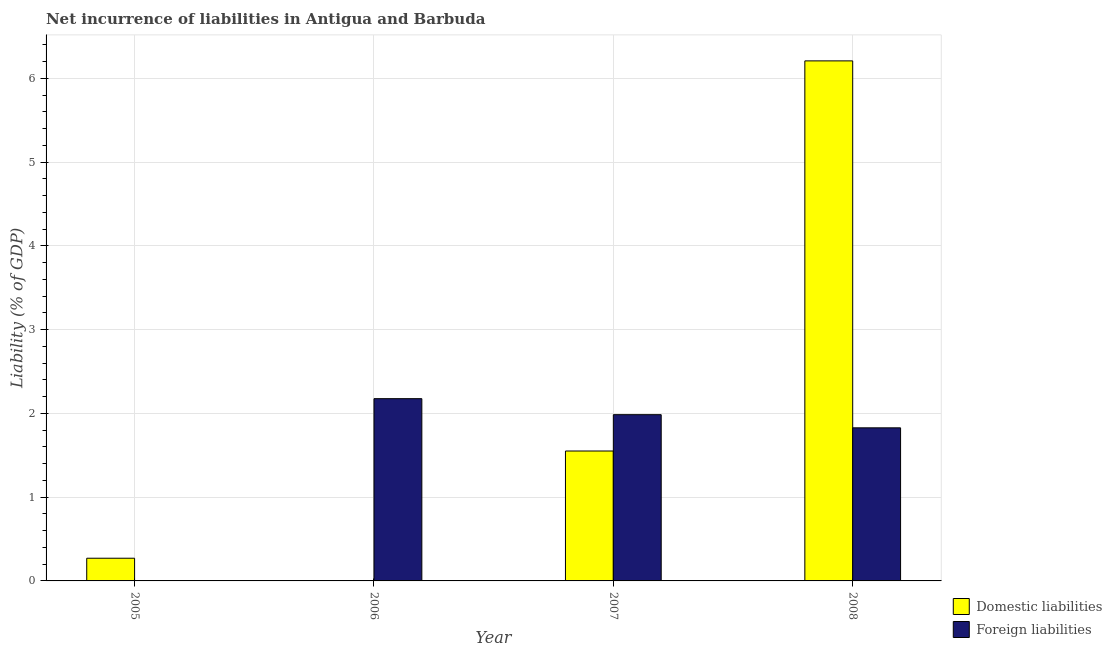Are the number of bars on each tick of the X-axis equal?
Ensure brevity in your answer.  No. What is the label of the 2nd group of bars from the left?
Make the answer very short. 2006. In how many cases, is the number of bars for a given year not equal to the number of legend labels?
Offer a terse response. 2. What is the incurrence of domestic liabilities in 2008?
Your response must be concise. 6.21. Across all years, what is the maximum incurrence of foreign liabilities?
Offer a terse response. 2.18. Across all years, what is the minimum incurrence of foreign liabilities?
Provide a short and direct response. 0. What is the total incurrence of foreign liabilities in the graph?
Your answer should be very brief. 5.99. What is the difference between the incurrence of domestic liabilities in 2005 and that in 2007?
Ensure brevity in your answer.  -1.28. What is the difference between the incurrence of domestic liabilities in 2006 and the incurrence of foreign liabilities in 2007?
Your response must be concise. -1.55. What is the average incurrence of domestic liabilities per year?
Your answer should be very brief. 2.01. In the year 2006, what is the difference between the incurrence of foreign liabilities and incurrence of domestic liabilities?
Your answer should be very brief. 0. In how many years, is the incurrence of domestic liabilities greater than 6 %?
Give a very brief answer. 1. What is the ratio of the incurrence of foreign liabilities in 2007 to that in 2008?
Offer a very short reply. 1.09. Is the incurrence of foreign liabilities in 2007 less than that in 2008?
Provide a succinct answer. No. What is the difference between the highest and the second highest incurrence of domestic liabilities?
Keep it short and to the point. 4.66. What is the difference between the highest and the lowest incurrence of foreign liabilities?
Offer a terse response. 2.18. In how many years, is the incurrence of domestic liabilities greater than the average incurrence of domestic liabilities taken over all years?
Ensure brevity in your answer.  1. Is the sum of the incurrence of domestic liabilities in 2007 and 2008 greater than the maximum incurrence of foreign liabilities across all years?
Make the answer very short. Yes. How many bars are there?
Provide a short and direct response. 6. Are the values on the major ticks of Y-axis written in scientific E-notation?
Offer a terse response. No. Does the graph contain any zero values?
Your answer should be compact. Yes. How many legend labels are there?
Give a very brief answer. 2. What is the title of the graph?
Provide a succinct answer. Net incurrence of liabilities in Antigua and Barbuda. Does "RDB concessional" appear as one of the legend labels in the graph?
Provide a succinct answer. No. What is the label or title of the X-axis?
Make the answer very short. Year. What is the label or title of the Y-axis?
Your answer should be compact. Liability (% of GDP). What is the Liability (% of GDP) in Domestic liabilities in 2005?
Keep it short and to the point. 0.27. What is the Liability (% of GDP) in Domestic liabilities in 2006?
Provide a short and direct response. 0. What is the Liability (% of GDP) in Foreign liabilities in 2006?
Offer a terse response. 2.18. What is the Liability (% of GDP) of Domestic liabilities in 2007?
Provide a succinct answer. 1.55. What is the Liability (% of GDP) in Foreign liabilities in 2007?
Your answer should be very brief. 1.99. What is the Liability (% of GDP) in Domestic liabilities in 2008?
Make the answer very short. 6.21. What is the Liability (% of GDP) in Foreign liabilities in 2008?
Ensure brevity in your answer.  1.83. Across all years, what is the maximum Liability (% of GDP) of Domestic liabilities?
Provide a short and direct response. 6.21. Across all years, what is the maximum Liability (% of GDP) of Foreign liabilities?
Give a very brief answer. 2.18. What is the total Liability (% of GDP) of Domestic liabilities in the graph?
Provide a short and direct response. 8.03. What is the total Liability (% of GDP) of Foreign liabilities in the graph?
Your answer should be very brief. 5.99. What is the difference between the Liability (% of GDP) in Domestic liabilities in 2005 and that in 2007?
Provide a succinct answer. -1.28. What is the difference between the Liability (% of GDP) of Domestic liabilities in 2005 and that in 2008?
Keep it short and to the point. -5.94. What is the difference between the Liability (% of GDP) in Foreign liabilities in 2006 and that in 2007?
Give a very brief answer. 0.19. What is the difference between the Liability (% of GDP) in Foreign liabilities in 2006 and that in 2008?
Ensure brevity in your answer.  0.35. What is the difference between the Liability (% of GDP) in Domestic liabilities in 2007 and that in 2008?
Ensure brevity in your answer.  -4.66. What is the difference between the Liability (% of GDP) of Foreign liabilities in 2007 and that in 2008?
Keep it short and to the point. 0.16. What is the difference between the Liability (% of GDP) in Domestic liabilities in 2005 and the Liability (% of GDP) in Foreign liabilities in 2006?
Give a very brief answer. -1.91. What is the difference between the Liability (% of GDP) in Domestic liabilities in 2005 and the Liability (% of GDP) in Foreign liabilities in 2007?
Your response must be concise. -1.71. What is the difference between the Liability (% of GDP) in Domestic liabilities in 2005 and the Liability (% of GDP) in Foreign liabilities in 2008?
Ensure brevity in your answer.  -1.56. What is the difference between the Liability (% of GDP) in Domestic liabilities in 2007 and the Liability (% of GDP) in Foreign liabilities in 2008?
Give a very brief answer. -0.28. What is the average Liability (% of GDP) of Domestic liabilities per year?
Your answer should be compact. 2.01. What is the average Liability (% of GDP) in Foreign liabilities per year?
Your answer should be compact. 1.5. In the year 2007, what is the difference between the Liability (% of GDP) of Domestic liabilities and Liability (% of GDP) of Foreign liabilities?
Your answer should be compact. -0.43. In the year 2008, what is the difference between the Liability (% of GDP) of Domestic liabilities and Liability (% of GDP) of Foreign liabilities?
Provide a succinct answer. 4.38. What is the ratio of the Liability (% of GDP) in Domestic liabilities in 2005 to that in 2007?
Ensure brevity in your answer.  0.17. What is the ratio of the Liability (% of GDP) in Domestic liabilities in 2005 to that in 2008?
Your answer should be compact. 0.04. What is the ratio of the Liability (% of GDP) in Foreign liabilities in 2006 to that in 2007?
Ensure brevity in your answer.  1.1. What is the ratio of the Liability (% of GDP) of Foreign liabilities in 2006 to that in 2008?
Your answer should be very brief. 1.19. What is the ratio of the Liability (% of GDP) in Domestic liabilities in 2007 to that in 2008?
Give a very brief answer. 0.25. What is the ratio of the Liability (% of GDP) in Foreign liabilities in 2007 to that in 2008?
Make the answer very short. 1.09. What is the difference between the highest and the second highest Liability (% of GDP) in Domestic liabilities?
Ensure brevity in your answer.  4.66. What is the difference between the highest and the second highest Liability (% of GDP) of Foreign liabilities?
Provide a short and direct response. 0.19. What is the difference between the highest and the lowest Liability (% of GDP) in Domestic liabilities?
Your answer should be very brief. 6.21. What is the difference between the highest and the lowest Liability (% of GDP) in Foreign liabilities?
Your answer should be very brief. 2.18. 